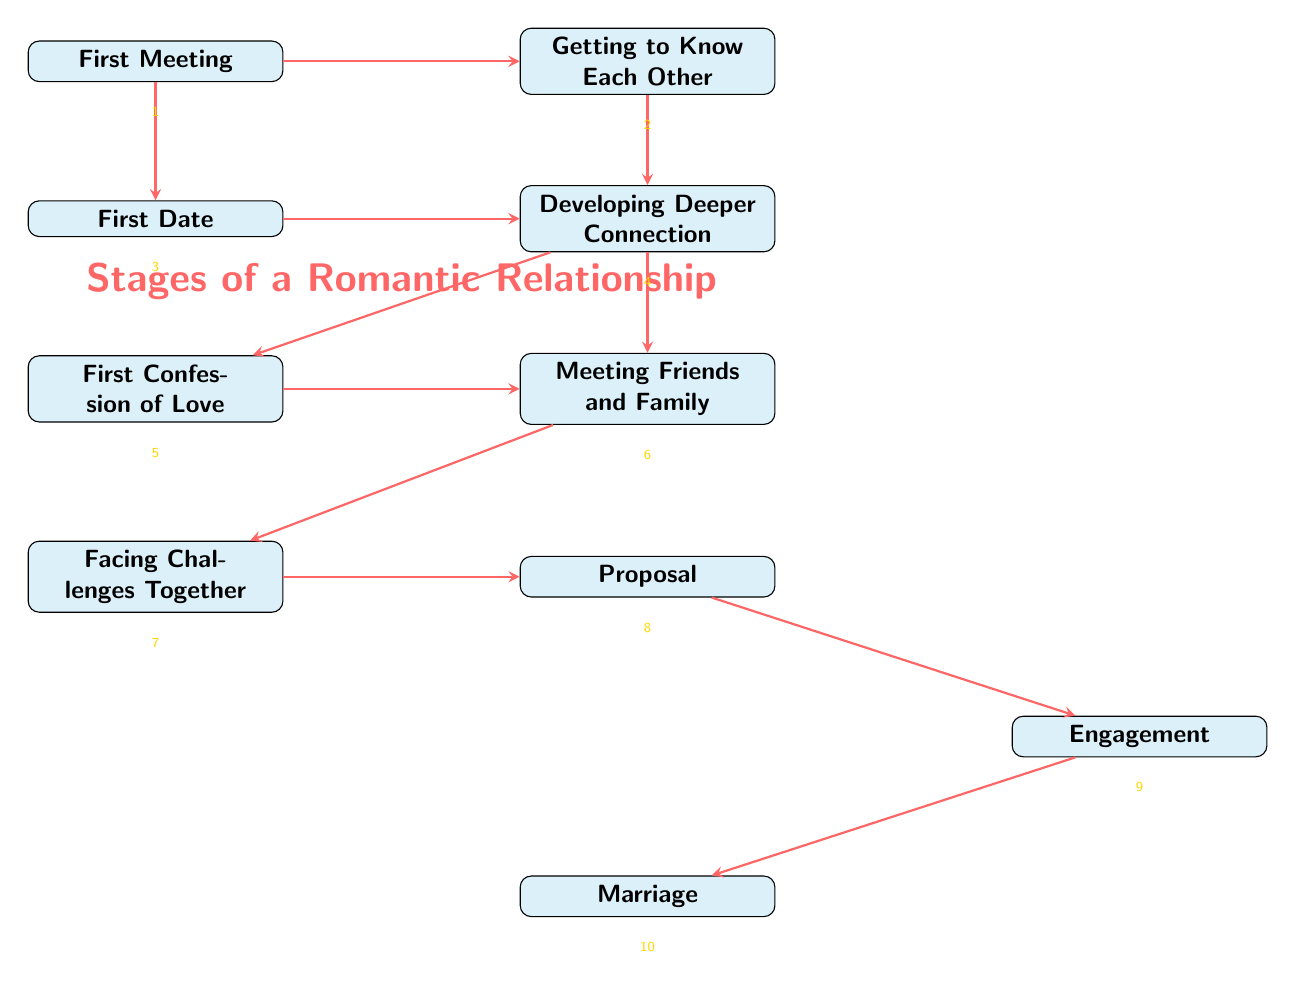What is the first stage in the romantic relationship? The first stage, as depicted in the diagram, is labeled "First Meeting."
Answer: First Meeting How many stages are there in total? By counting each stage node in the diagram, there are ten stages.
Answer: 10 What comes after "First Confession of Love"? According to the flow in the diagram, after "First Confession of Love," the next stage is "Meeting Friends and Family."
Answer: Meeting Friends and Family Which stage describes overcoming obstacles? The stage that focuses on overcoming challenges is labeled "Facing Challenges Together."
Answer: Facing Challenges Together What is the final stage of the romantic relationship? The last stage indicated in the diagram is "Marriage."
Answer: Marriage What is the relationship between "Proposal" and "Engagement"? The diagram shows that "Proposal" precedes "Engagement," indicating a sequence where the proposal leads into the engagement period.
Answer: Proposal precedes Engagement In which stage is love first confessed? The stage specifically designated for the first verbal expression of love is "First Confession of Love."
Answer: First Confession of Love Which two stages can occur after "Developing Deeper Connection"? Following "Developing Deeper Connection," the next stages to occur are "First Confession of Love" and "Meeting Friends and Family."
Answer: First Confession of Love and Meeting Friends and Family What represents the transition from engagement to marriage? The transition is illustrated by the arrow leading directly from "Engagement" to "Marriage" in the diagram.
Answer: Arrow from Engagement to Marriage 